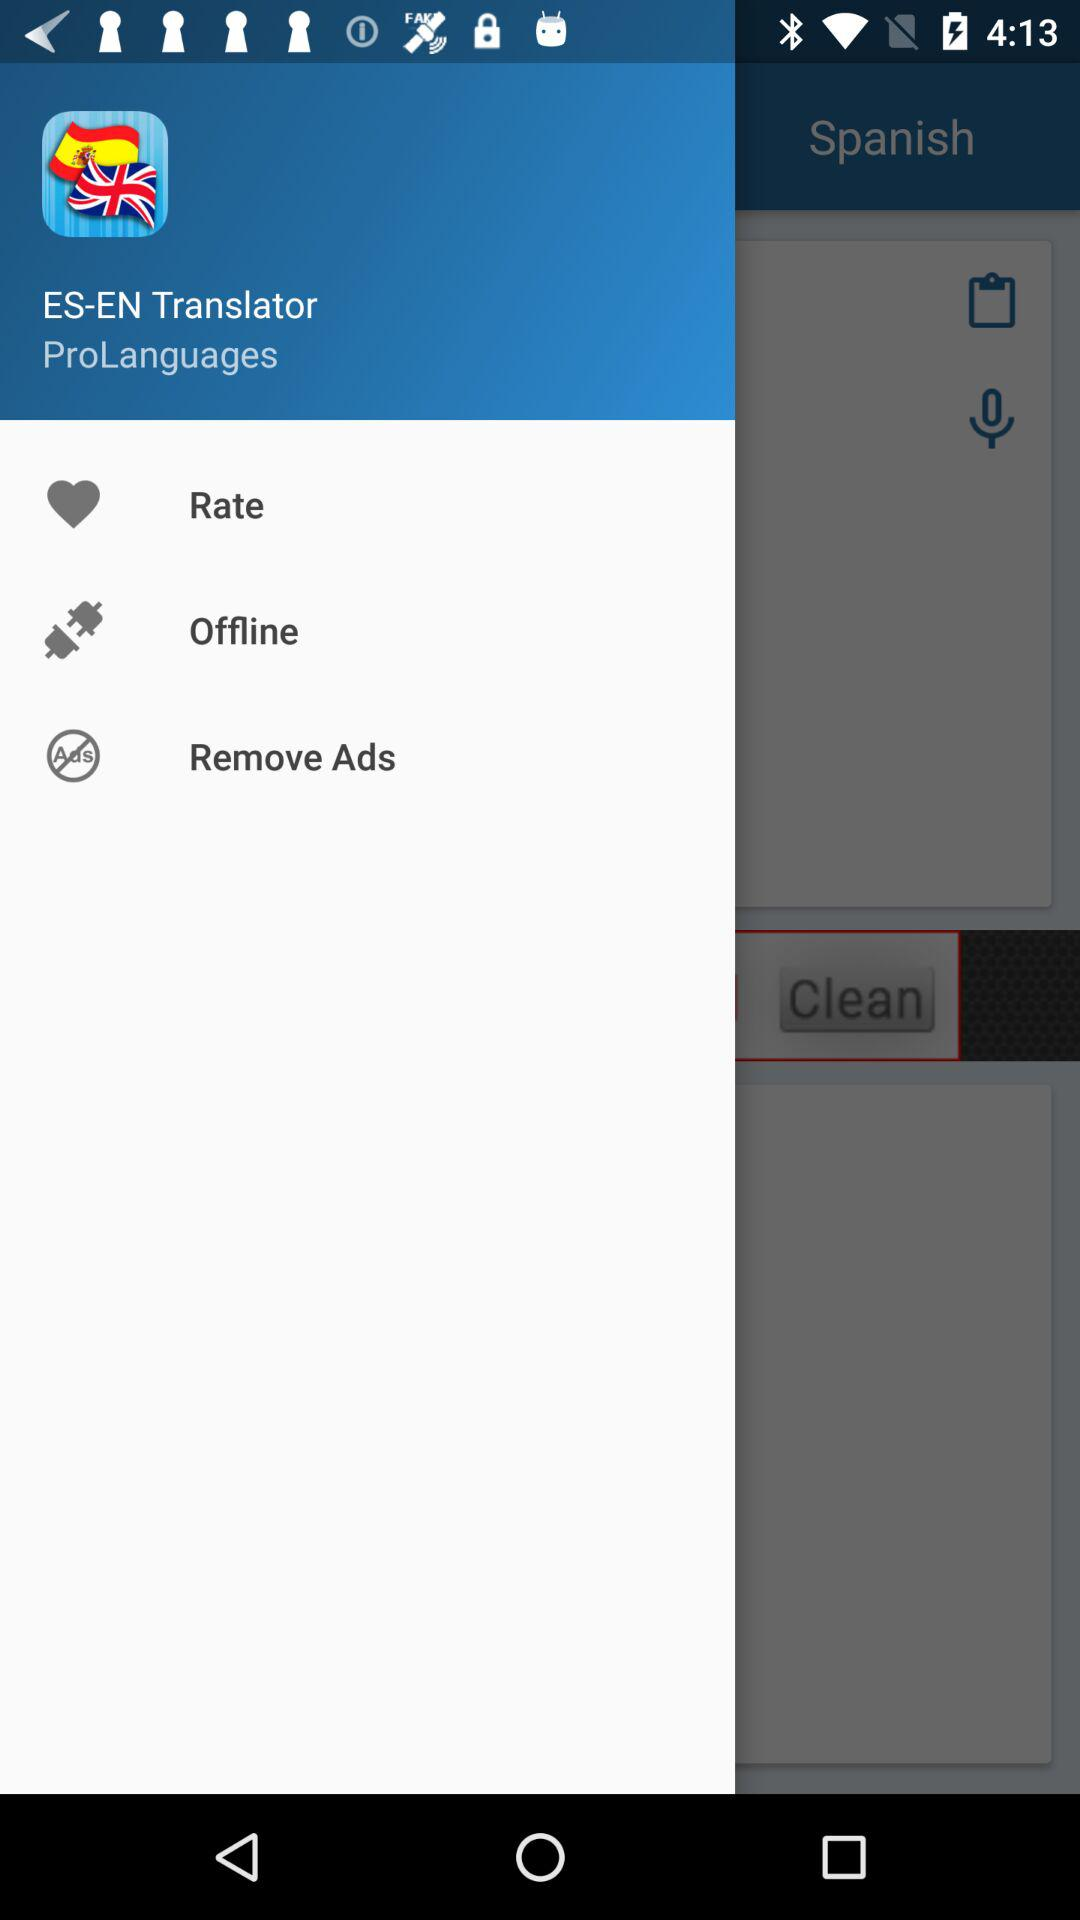What is the name of the application? The name of the application is "ES-EN Translator". 